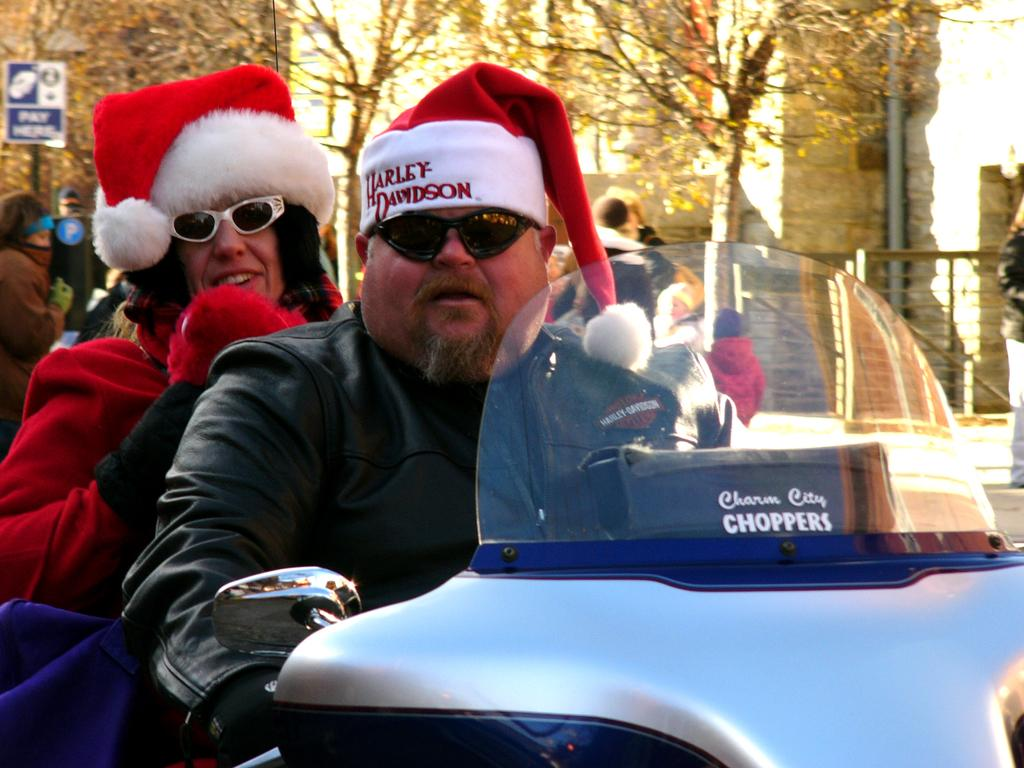Who can be seen in the image? There is a man and a woman in the image. What are they doing in the image? They are sitting on a vehicle. Are there any other people visible in the image? Yes, there are people visible at the back of the vehicle. What can be seen in the background of the image? There are trees in the background of the image. What else is present in the image besides the people and trees? There is a signboard on a pole in the image. What color is the paint used to decorate the square box in the image? There is no square box or paint present in the image. 